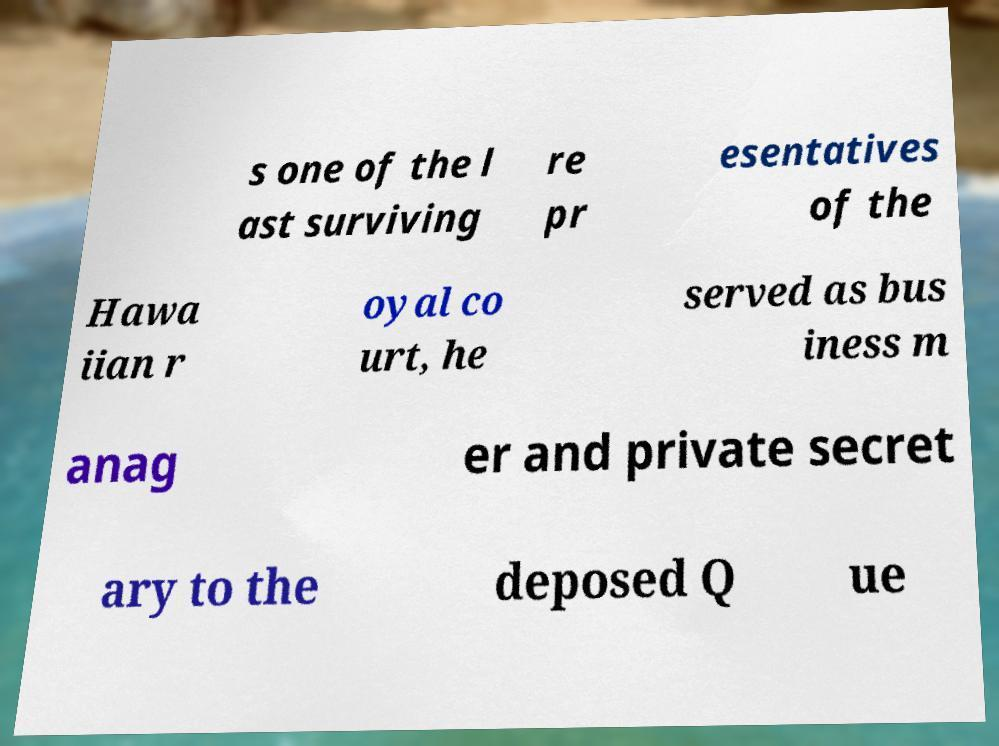Can you read and provide the text displayed in the image?This photo seems to have some interesting text. Can you extract and type it out for me? s one of the l ast surviving re pr esentatives of the Hawa iian r oyal co urt, he served as bus iness m anag er and private secret ary to the deposed Q ue 